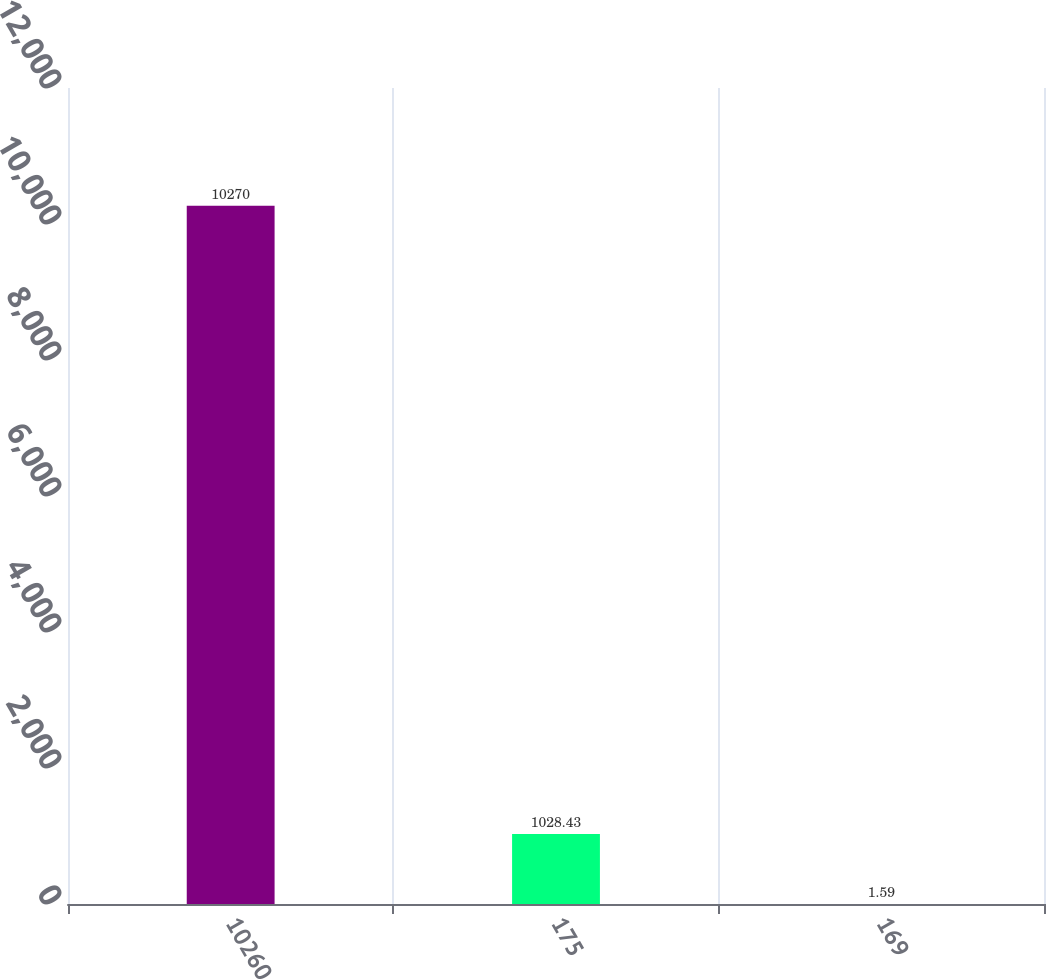Convert chart. <chart><loc_0><loc_0><loc_500><loc_500><bar_chart><fcel>10260<fcel>175<fcel>169<nl><fcel>10270<fcel>1028.43<fcel>1.59<nl></chart> 